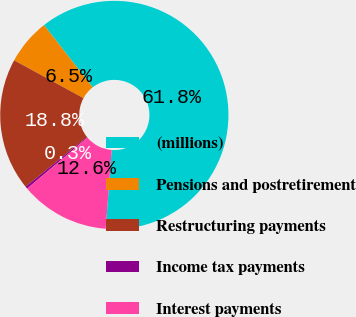<chart> <loc_0><loc_0><loc_500><loc_500><pie_chart><fcel>(millions)<fcel>Pensions and postretirement<fcel>Restructuring payments<fcel>Income tax payments<fcel>Interest payments<nl><fcel>61.78%<fcel>6.48%<fcel>18.77%<fcel>0.34%<fcel>12.63%<nl></chart> 